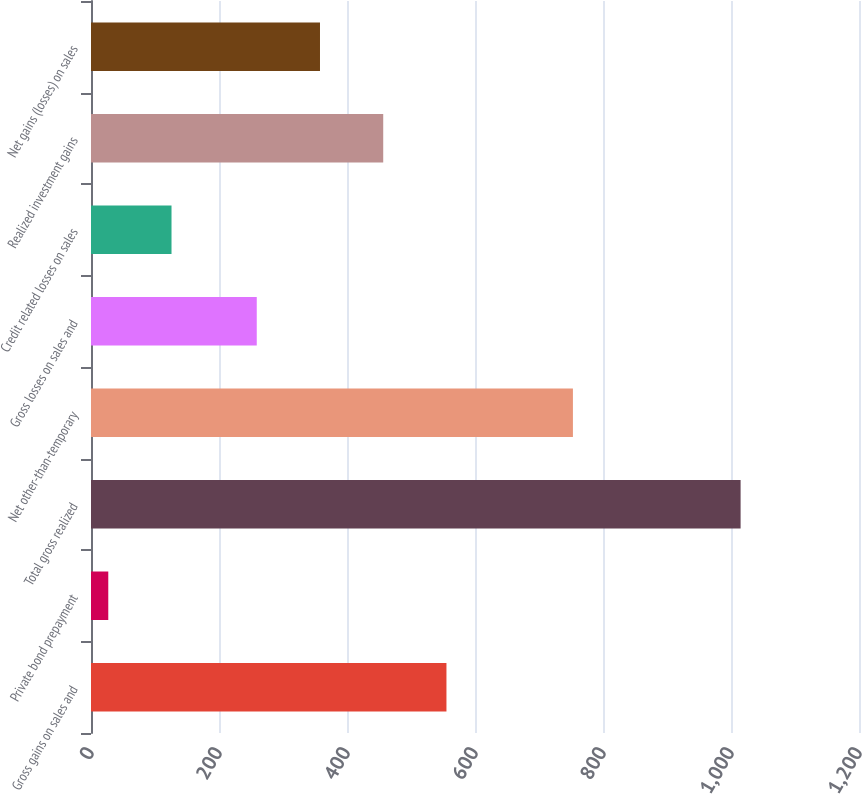Convert chart to OTSL. <chart><loc_0><loc_0><loc_500><loc_500><bar_chart><fcel>Gross gains on sales and<fcel>Private bond prepayment<fcel>Total gross realized<fcel>Net other-than-temporary<fcel>Gross losses on sales and<fcel>Credit related losses on sales<fcel>Realized investment gains<fcel>Net gains (losses) on sales<nl><fcel>555.4<fcel>27<fcel>1015<fcel>753<fcel>259<fcel>125.8<fcel>456.6<fcel>357.8<nl></chart> 